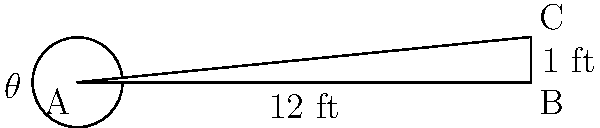A new community center is being built with accessibility in mind. The architect needs to design a wheelchair ramp that meets the standard inclination angle for easy access. If the ramp needs to rise 1 foot over a horizontal distance of 12 feet, what is the angle of inclination ($\theta$) of the ramp? To find the angle of inclination, we can use basic trigonometry:

1) In the right triangle ABC, we know:
   - The opposite side (rise) = 1 foot
   - The adjacent side (run) = 12 feet

2) We can use the tangent function to find the angle:

   $\tan(\theta) = \frac{\text{opposite}}{\text{adjacent}} = \frac{1}{12}$

3) To find $\theta$, we need to use the inverse tangent (arctan or $\tan^{-1}$):

   $\theta = \tan^{-1}(\frac{1}{12})$

4) Using a calculator or trigonometric tables:

   $\theta \approx 4.76^\circ$

5) Rounding to the nearest degree:

   $\theta \approx 5^\circ$

This angle meets the standard for wheelchair ramps, which typically require a slope of 1:12 or less (equivalent to about 4.8° or less).
Answer: $5^\circ$ 